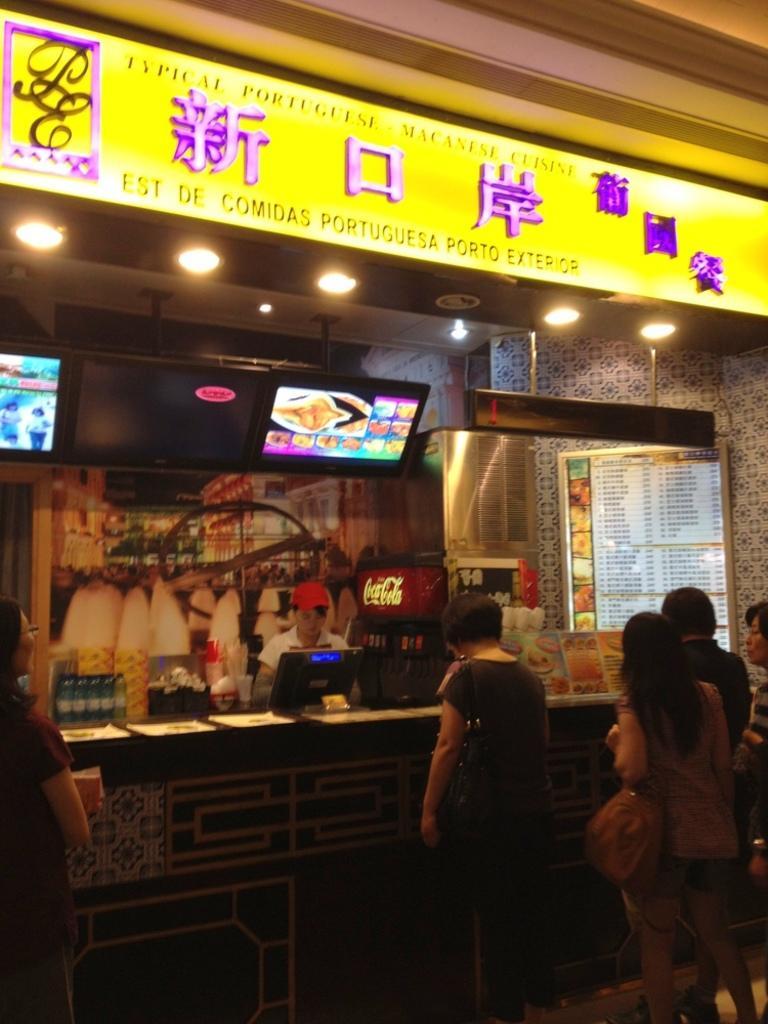How would you summarize this image in a sentence or two? Here we can see few people. There are bottles, monitor, boards, screens, papers, and lights. There is a wall. 